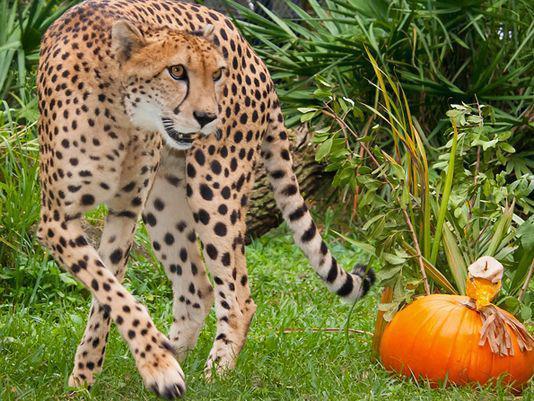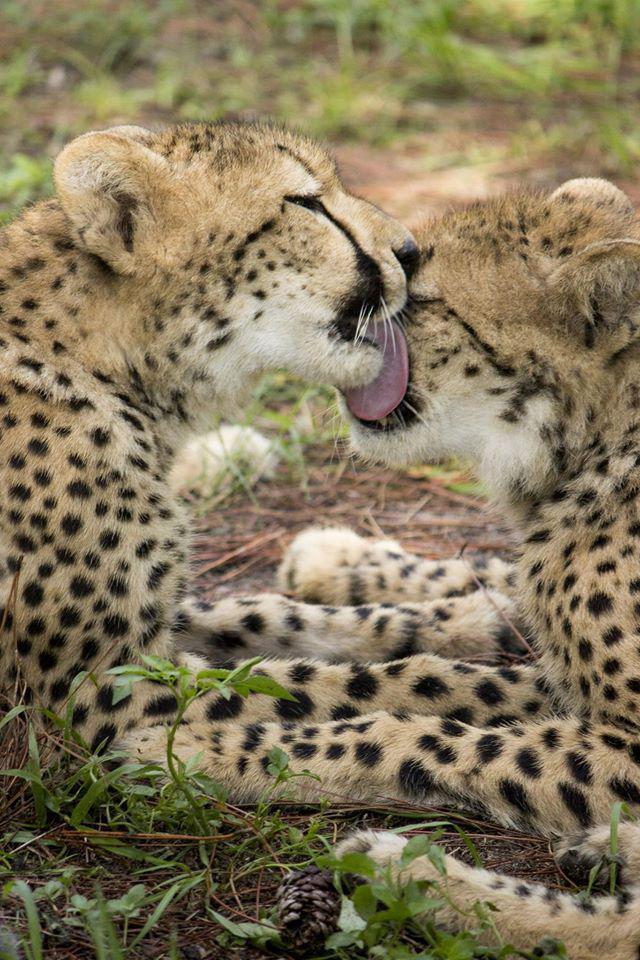The first image is the image on the left, the second image is the image on the right. Given the left and right images, does the statement "There are two leopards in one of the images." hold true? Answer yes or no. Yes. The first image is the image on the left, the second image is the image on the right. Evaluate the accuracy of this statement regarding the images: "There are 3 cheetahs.". Is it true? Answer yes or no. Yes. 